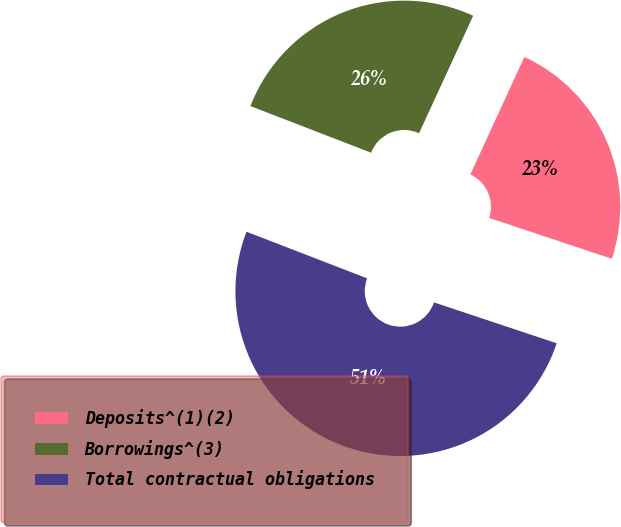Convert chart. <chart><loc_0><loc_0><loc_500><loc_500><pie_chart><fcel>Deposits^(1)(2)<fcel>Borrowings^(3)<fcel>Total contractual obligations<nl><fcel>23.25%<fcel>26.0%<fcel>50.75%<nl></chart> 